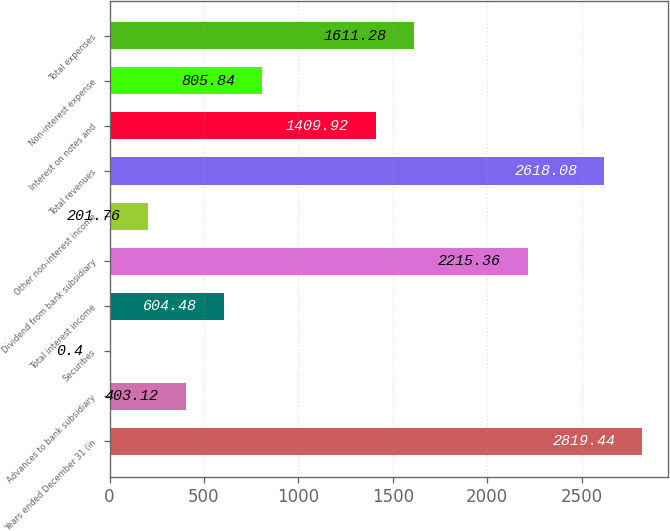<chart> <loc_0><loc_0><loc_500><loc_500><bar_chart><fcel>Years ended December 31 (in<fcel>Advances to bank subsidiary<fcel>Securities<fcel>Total interest income<fcel>Dividend from bank subsidiary<fcel>Other non-interest income<fcel>Total revenues<fcel>Interest on notes and<fcel>Non-interest expense<fcel>Total expenses<nl><fcel>2819.44<fcel>403.12<fcel>0.4<fcel>604.48<fcel>2215.36<fcel>201.76<fcel>2618.08<fcel>1409.92<fcel>805.84<fcel>1611.28<nl></chart> 